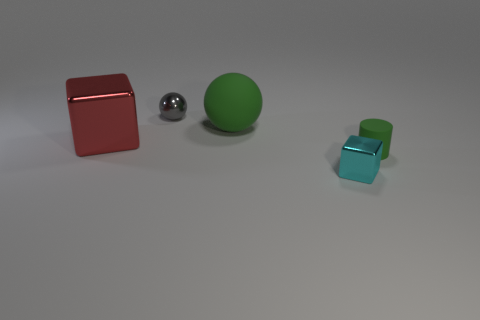Add 4 tiny shiny spheres. How many objects exist? 9 Subtract all cylinders. How many objects are left? 4 Add 3 green rubber objects. How many green rubber objects exist? 5 Subtract 0 brown balls. How many objects are left? 5 Subtract all red balls. Subtract all red cubes. How many balls are left? 2 Subtract all small red metallic cylinders. Subtract all tiny objects. How many objects are left? 2 Add 1 small shiny cubes. How many small shiny cubes are left? 2 